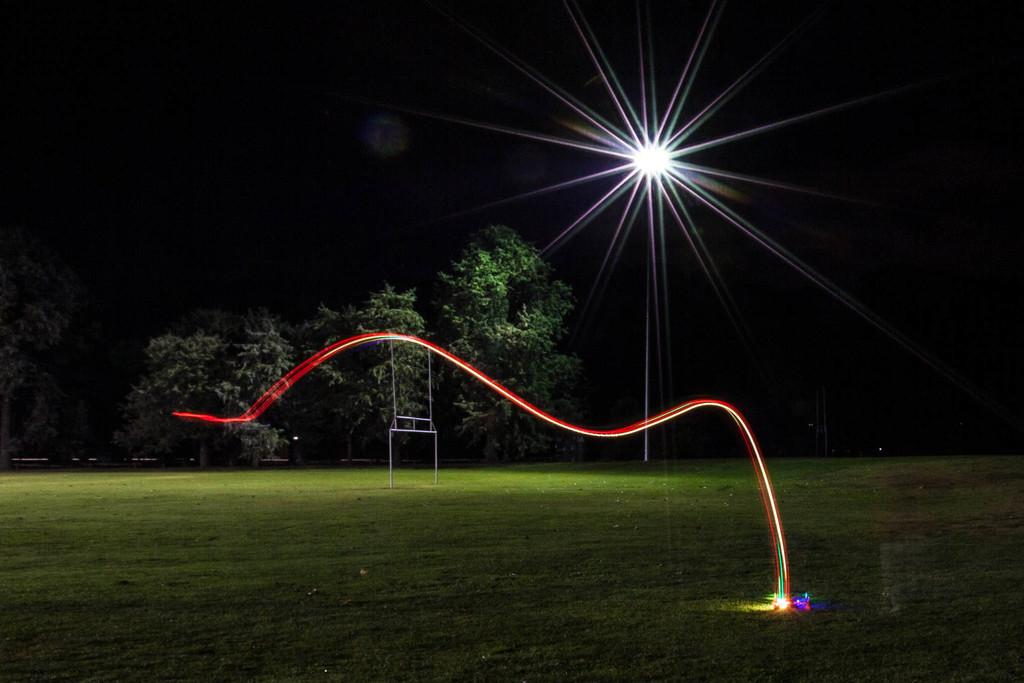What type of terrain is visible in the image? There is an open grass ground in the image. What natural elements can be seen in the image? There are multiple trees in the image. Are there any artificial elements visible in the image? Yes, there are lights visible in the image. How would you describe the overall lighting in the image? The image appears to be slightly dark. What type of comb is being used to create a rhythm in the image? There is no comb or rhythm present in the image; it features an open grass ground, trees, and lights. 